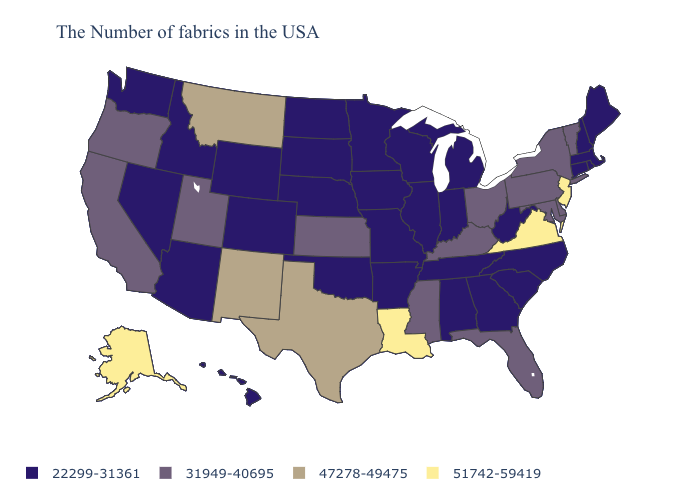What is the highest value in the West ?
Be succinct. 51742-59419. Which states have the highest value in the USA?
Concise answer only. New Jersey, Virginia, Louisiana, Alaska. Name the states that have a value in the range 31949-40695?
Give a very brief answer. Vermont, New York, Delaware, Maryland, Pennsylvania, Ohio, Florida, Kentucky, Mississippi, Kansas, Utah, California, Oregon. How many symbols are there in the legend?
Keep it brief. 4. What is the highest value in states that border South Dakota?
Quick response, please. 47278-49475. What is the value of Tennessee?
Write a very short answer. 22299-31361. Which states have the highest value in the USA?
Quick response, please. New Jersey, Virginia, Louisiana, Alaska. Name the states that have a value in the range 51742-59419?
Give a very brief answer. New Jersey, Virginia, Louisiana, Alaska. What is the value of Missouri?
Answer briefly. 22299-31361. What is the value of Arizona?
Quick response, please. 22299-31361. Name the states that have a value in the range 22299-31361?
Short answer required. Maine, Massachusetts, Rhode Island, New Hampshire, Connecticut, North Carolina, South Carolina, West Virginia, Georgia, Michigan, Indiana, Alabama, Tennessee, Wisconsin, Illinois, Missouri, Arkansas, Minnesota, Iowa, Nebraska, Oklahoma, South Dakota, North Dakota, Wyoming, Colorado, Arizona, Idaho, Nevada, Washington, Hawaii. What is the value of Utah?
Write a very short answer. 31949-40695. Does Virginia have the highest value in the USA?
Keep it brief. Yes. Name the states that have a value in the range 22299-31361?
Keep it brief. Maine, Massachusetts, Rhode Island, New Hampshire, Connecticut, North Carolina, South Carolina, West Virginia, Georgia, Michigan, Indiana, Alabama, Tennessee, Wisconsin, Illinois, Missouri, Arkansas, Minnesota, Iowa, Nebraska, Oklahoma, South Dakota, North Dakota, Wyoming, Colorado, Arizona, Idaho, Nevada, Washington, Hawaii. What is the value of Minnesota?
Answer briefly. 22299-31361. 